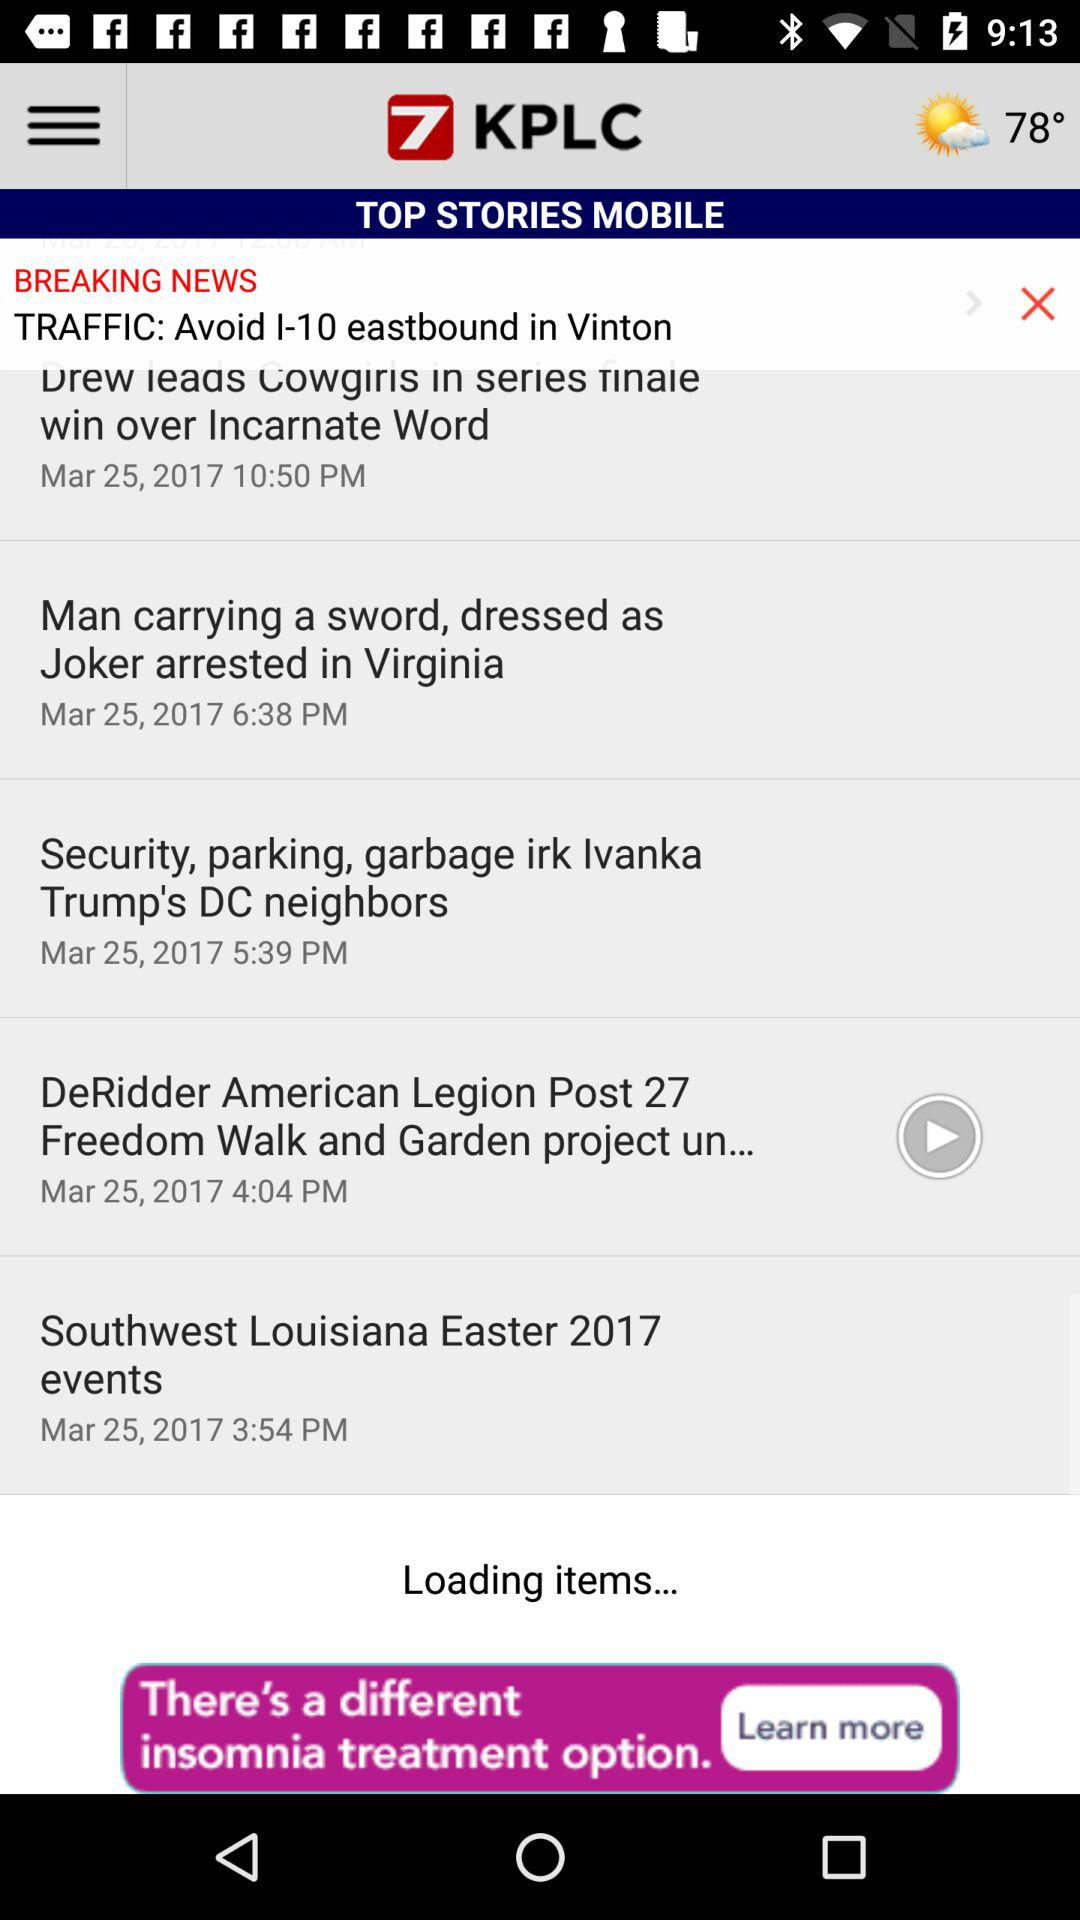What's the temperature? The temperature is 78°. 